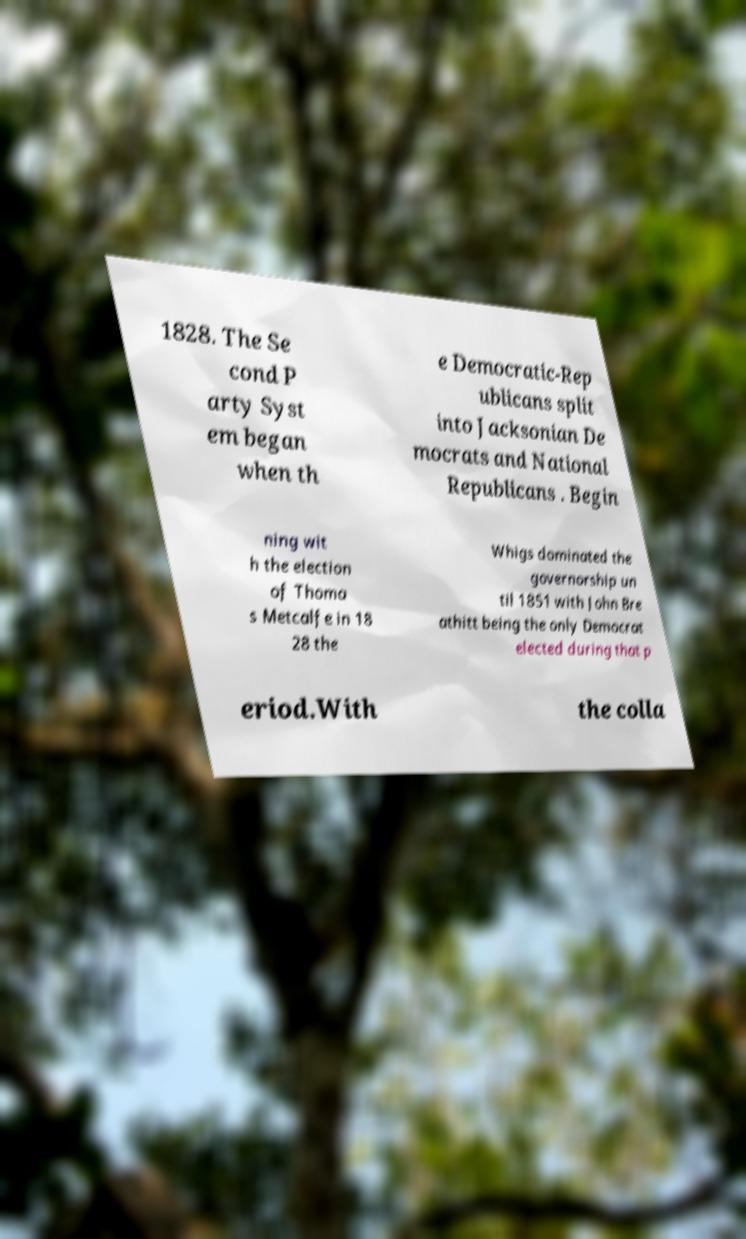There's text embedded in this image that I need extracted. Can you transcribe it verbatim? 1828. The Se cond P arty Syst em began when th e Democratic-Rep ublicans split into Jacksonian De mocrats and National Republicans . Begin ning wit h the election of Thoma s Metcalfe in 18 28 the Whigs dominated the governorship un til 1851 with John Bre athitt being the only Democrat elected during that p eriod.With the colla 